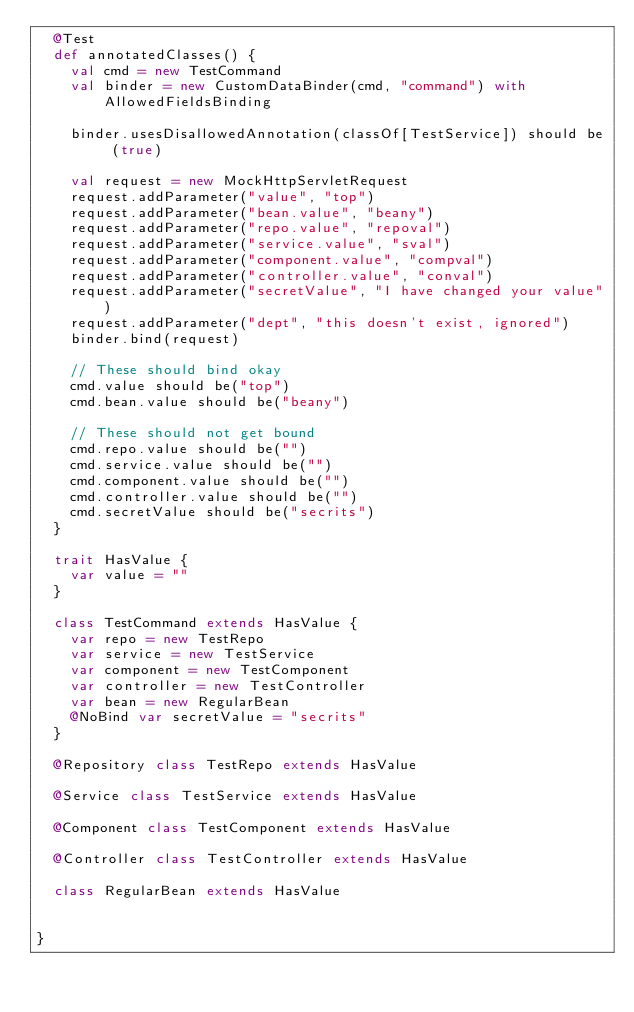<code> <loc_0><loc_0><loc_500><loc_500><_Scala_>  @Test
  def annotatedClasses() {
    val cmd = new TestCommand
    val binder = new CustomDataBinder(cmd, "command") with AllowedFieldsBinding

    binder.usesDisallowedAnnotation(classOf[TestService]) should be (true)

    val request = new MockHttpServletRequest
    request.addParameter("value", "top")
    request.addParameter("bean.value", "beany")
    request.addParameter("repo.value", "repoval")
    request.addParameter("service.value", "sval")
    request.addParameter("component.value", "compval")
    request.addParameter("controller.value", "conval")
    request.addParameter("secretValue", "I have changed your value")
    request.addParameter("dept", "this doesn't exist, ignored")
    binder.bind(request)

    // These should bind okay
    cmd.value should be("top")
    cmd.bean.value should be("beany")

    // These should not get bound
    cmd.repo.value should be("")
    cmd.service.value should be("")
    cmd.component.value should be("")
    cmd.controller.value should be("")
    cmd.secretValue should be("secrits")
  }

  trait HasValue {
    var value = ""
  }

  class TestCommand extends HasValue {
    var repo = new TestRepo
    var service = new TestService
    var component = new TestComponent
    var controller = new TestController
    var bean = new RegularBean
    @NoBind var secretValue = "secrits"
  }

  @Repository class TestRepo extends HasValue

  @Service class TestService extends HasValue

  @Component class TestComponent extends HasValue

  @Controller class TestController extends HasValue

  class RegularBean extends HasValue


}</code> 